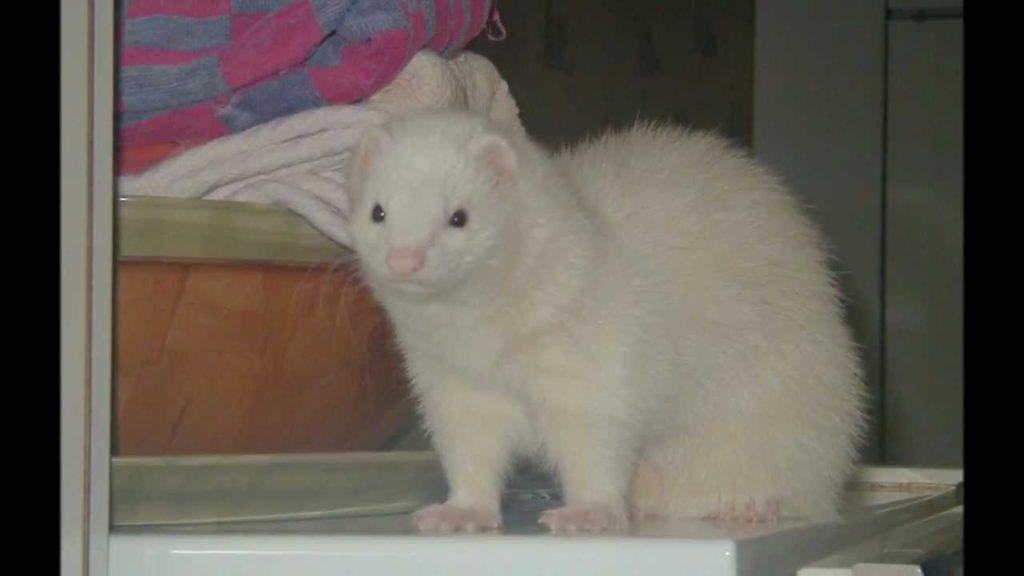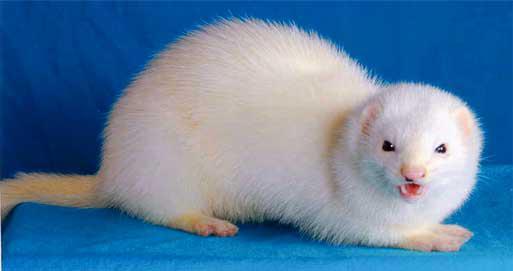The first image is the image on the left, the second image is the image on the right. For the images shown, is this caption "A person is holding up the animal in one of the images." true? Answer yes or no. No. 